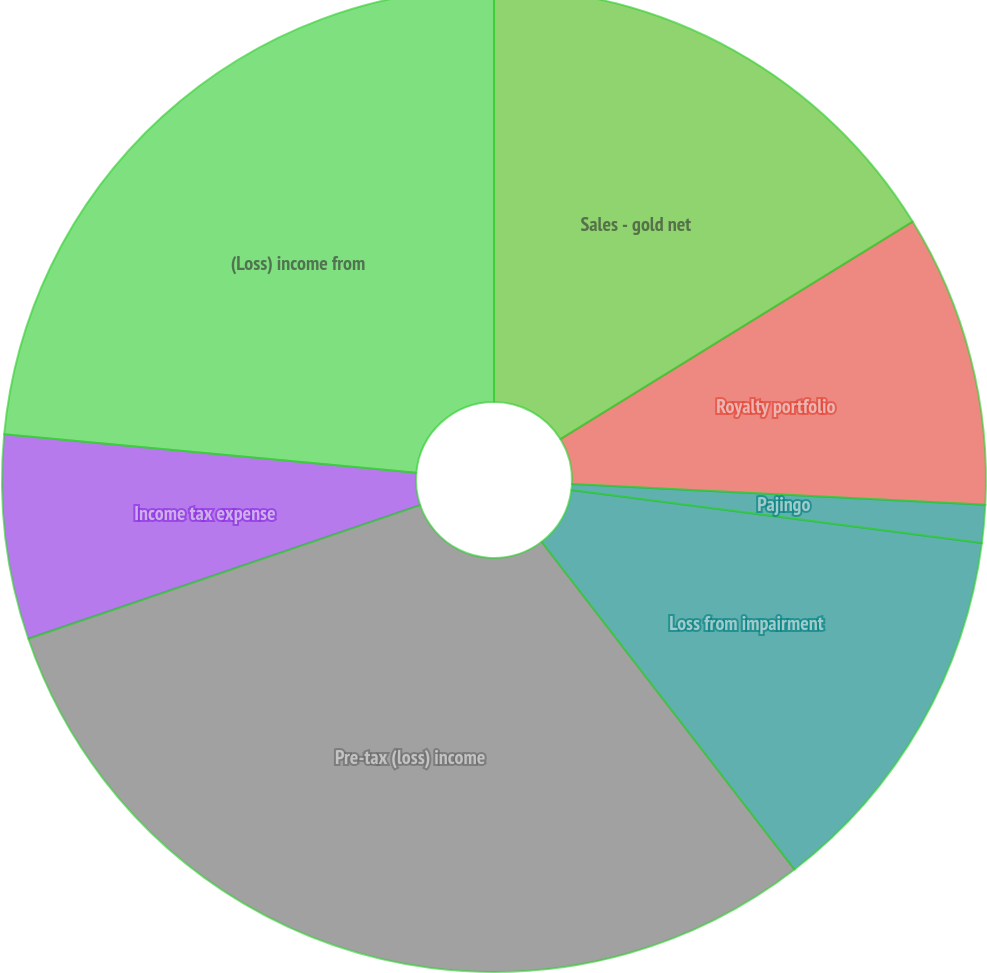<chart> <loc_0><loc_0><loc_500><loc_500><pie_chart><fcel>Sales - gold net<fcel>Royalty portfolio<fcel>Pajingo<fcel>Loss from impairment<fcel>Pre-tax (loss) income<fcel>Income tax expense<fcel>(Loss) income from<nl><fcel>16.2%<fcel>9.6%<fcel>1.24%<fcel>12.5%<fcel>30.23%<fcel>6.71%<fcel>23.52%<nl></chart> 